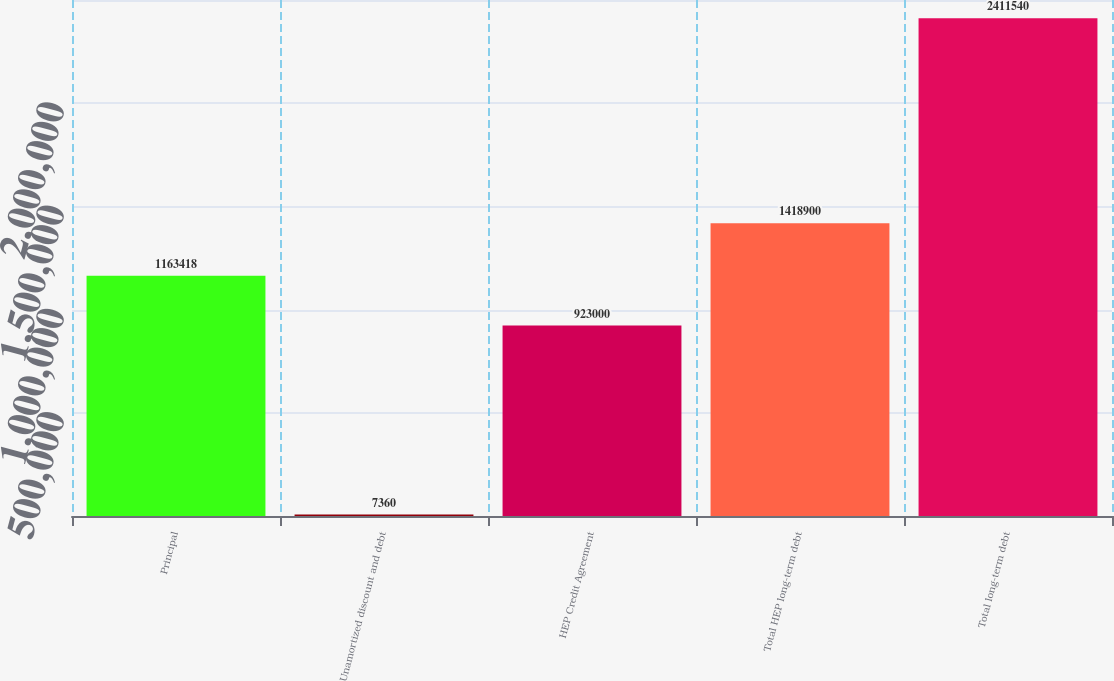Convert chart. <chart><loc_0><loc_0><loc_500><loc_500><bar_chart><fcel>Principal<fcel>Unamortized discount and debt<fcel>HEP Credit Agreement<fcel>Total HEP long-term debt<fcel>Total long-term debt<nl><fcel>1.16342e+06<fcel>7360<fcel>923000<fcel>1.4189e+06<fcel>2.41154e+06<nl></chart> 